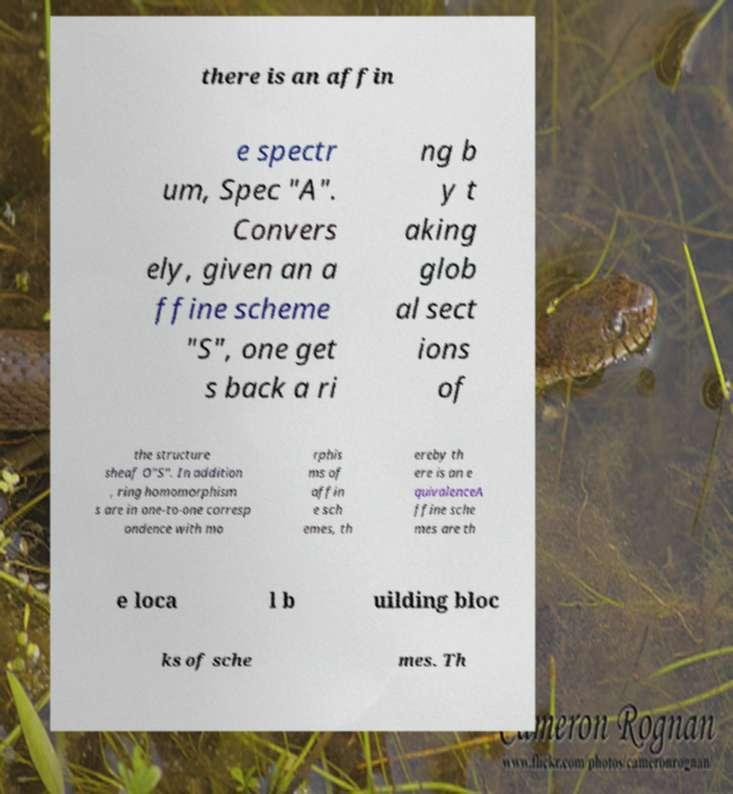Can you read and provide the text displayed in the image?This photo seems to have some interesting text. Can you extract and type it out for me? there is an affin e spectr um, Spec "A". Convers ely, given an a ffine scheme "S", one get s back a ri ng b y t aking glob al sect ions of the structure sheaf O"S". In addition , ring homomorphism s are in one-to-one corresp ondence with mo rphis ms of affin e sch emes, th ereby th ere is an e quivalenceA ffine sche mes are th e loca l b uilding bloc ks of sche mes. Th 